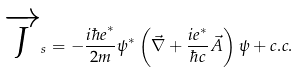<formula> <loc_0><loc_0><loc_500><loc_500>\overrightarrow { J } _ { s } = - \frac { i { \hbar { e } } ^ { \ast } } { 2 m } \psi ^ { \ast } \left ( \vec { \nabla } + \frac { i e ^ { \ast } } { \hbar { c } } \vec { A } \right ) \psi + c . c .</formula> 